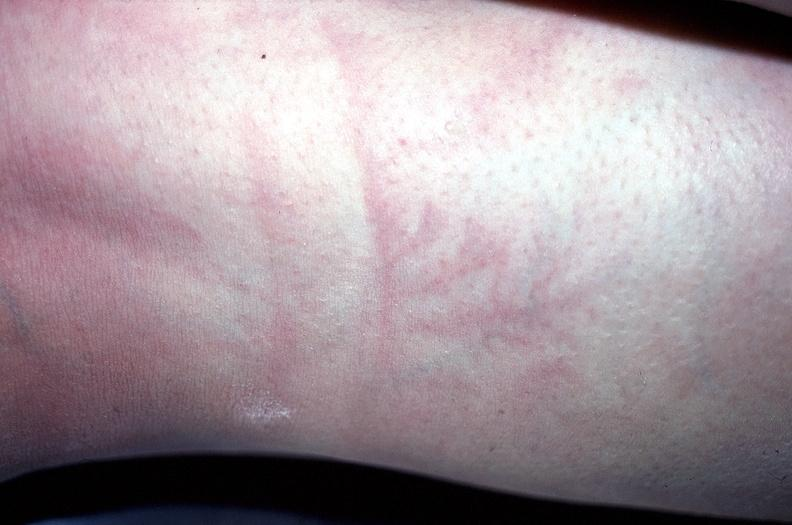does tuberculosis show arm, lightning strike - ferning?
Answer the question using a single word or phrase. No 